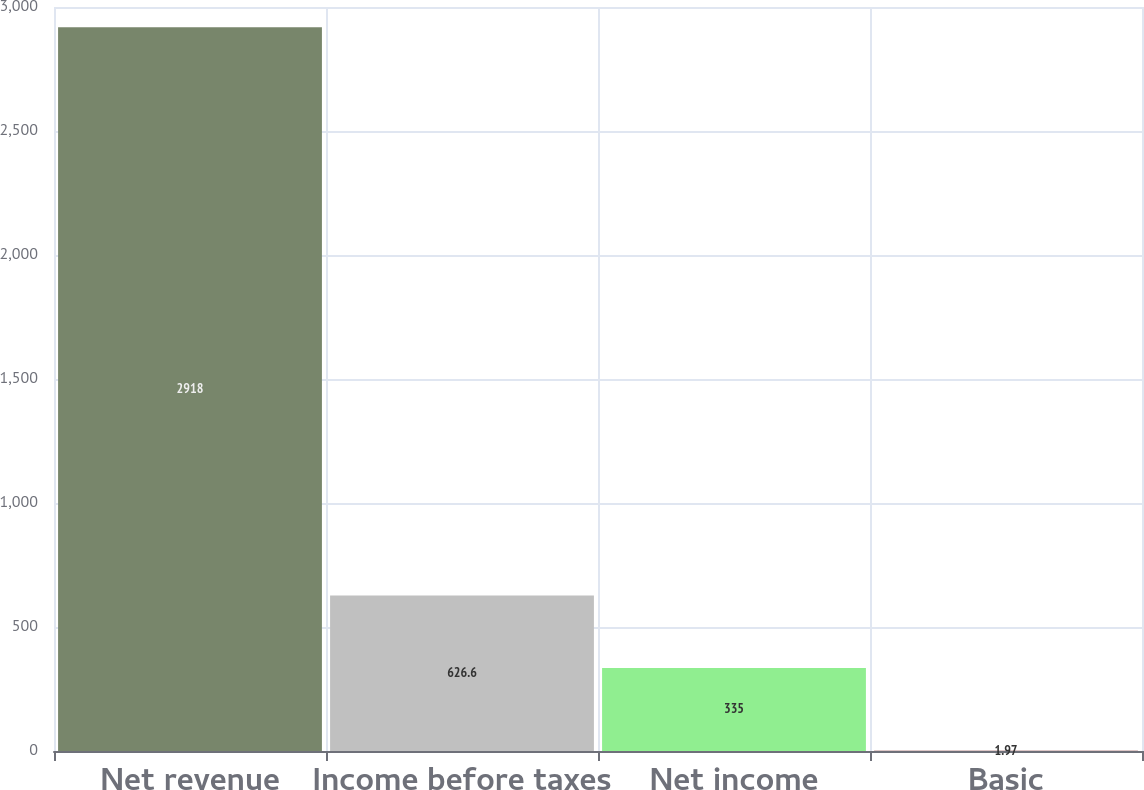<chart> <loc_0><loc_0><loc_500><loc_500><bar_chart><fcel>Net revenue<fcel>Income before taxes<fcel>Net income<fcel>Basic<nl><fcel>2918<fcel>626.6<fcel>335<fcel>1.97<nl></chart> 